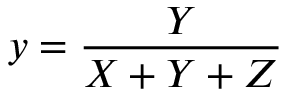Convert formula to latex. <formula><loc_0><loc_0><loc_500><loc_500>y = { \frac { Y } { X + Y + Z } }</formula> 